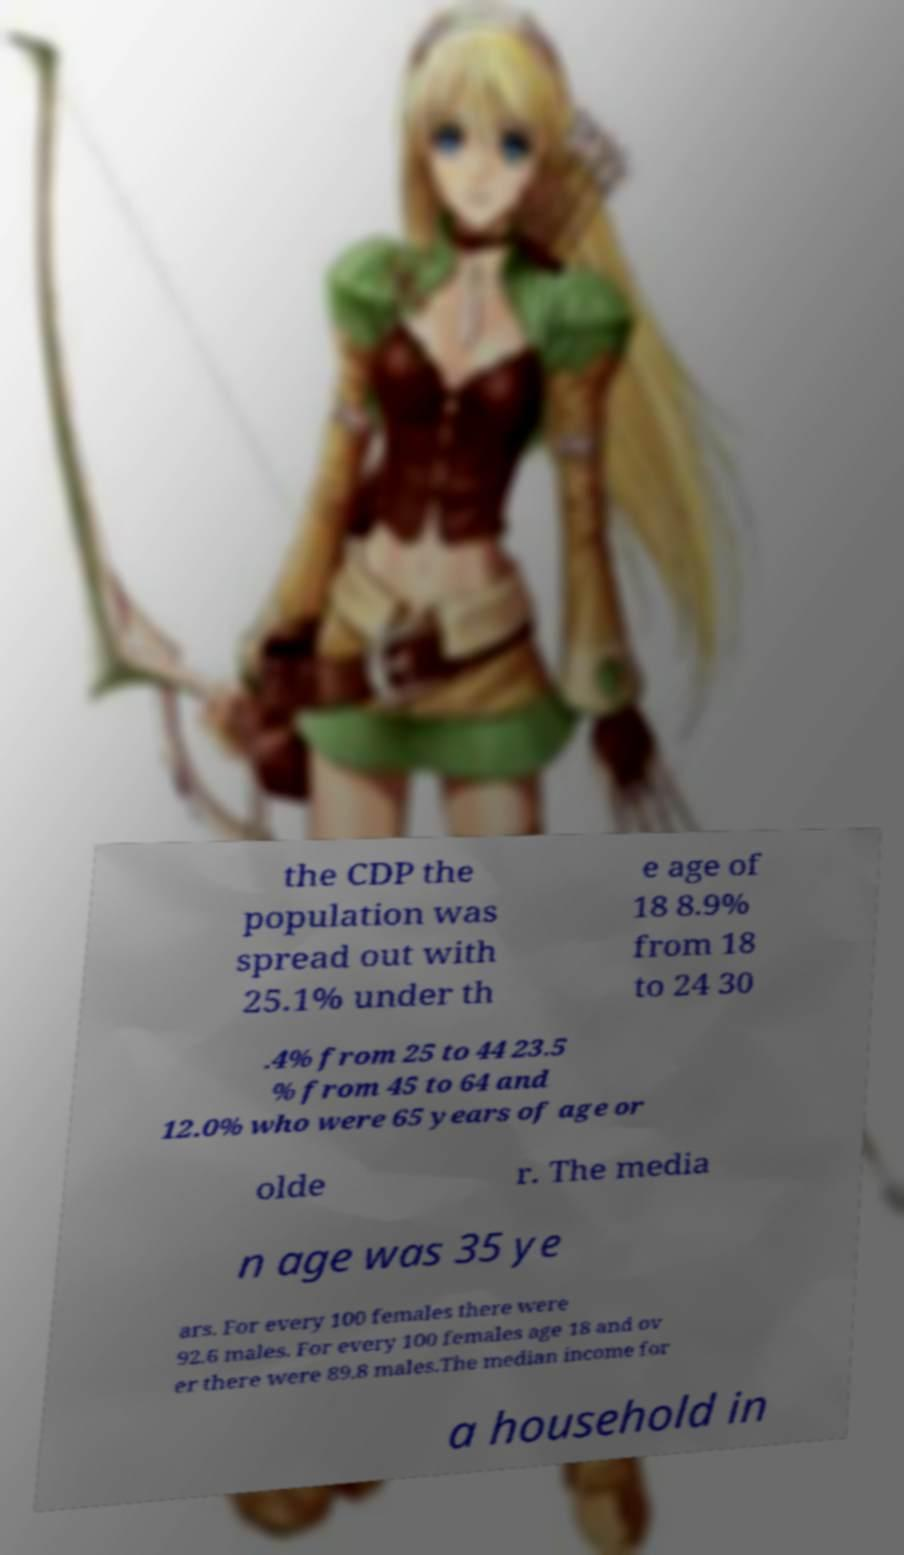Please read and relay the text visible in this image. What does it say? the CDP the population was spread out with 25.1% under th e age of 18 8.9% from 18 to 24 30 .4% from 25 to 44 23.5 % from 45 to 64 and 12.0% who were 65 years of age or olde r. The media n age was 35 ye ars. For every 100 females there were 92.6 males. For every 100 females age 18 and ov er there were 89.8 males.The median income for a household in 